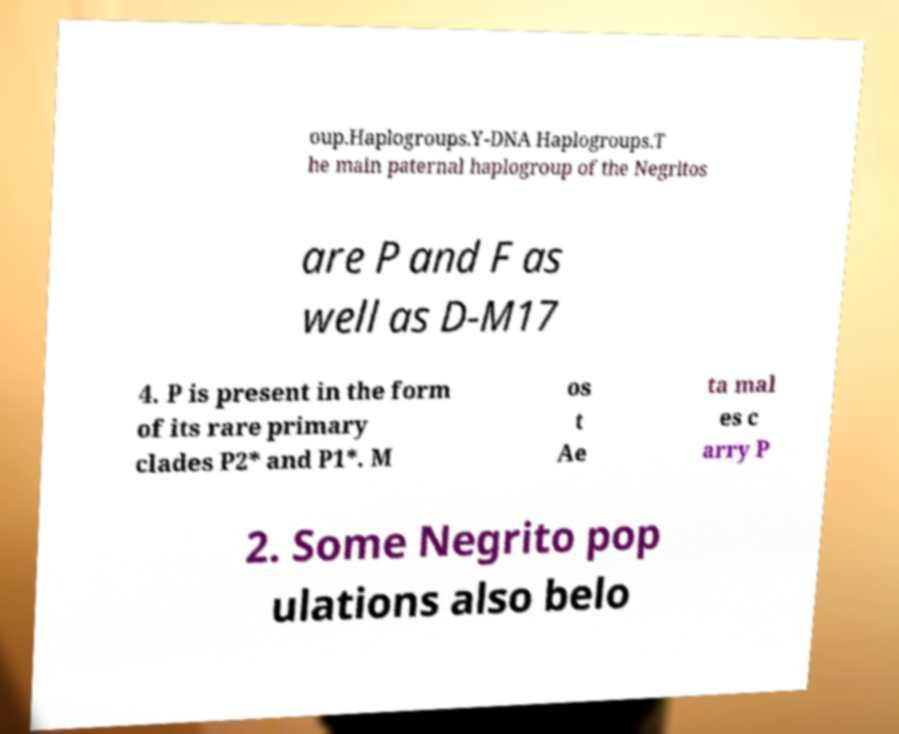Can you read and provide the text displayed in the image?This photo seems to have some interesting text. Can you extract and type it out for me? oup.Haplogroups.Y-DNA Haplogroups.T he main paternal haplogroup of the Negritos are P and F as well as D-M17 4. P is present in the form of its rare primary clades P2* and P1*. M os t Ae ta mal es c arry P 2. Some Negrito pop ulations also belo 